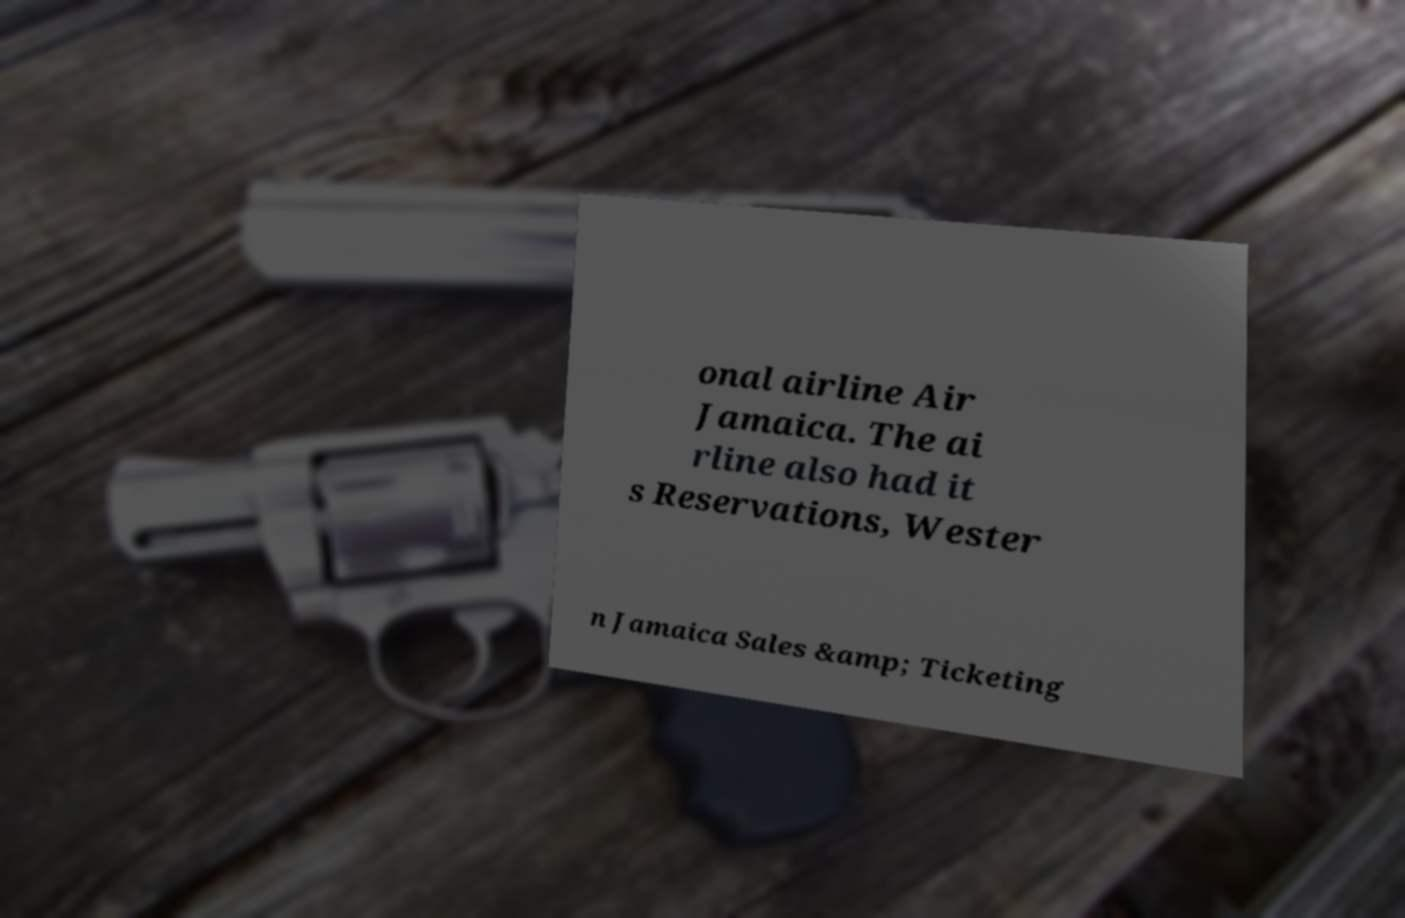Please read and relay the text visible in this image. What does it say? onal airline Air Jamaica. The ai rline also had it s Reservations, Wester n Jamaica Sales &amp; Ticketing 